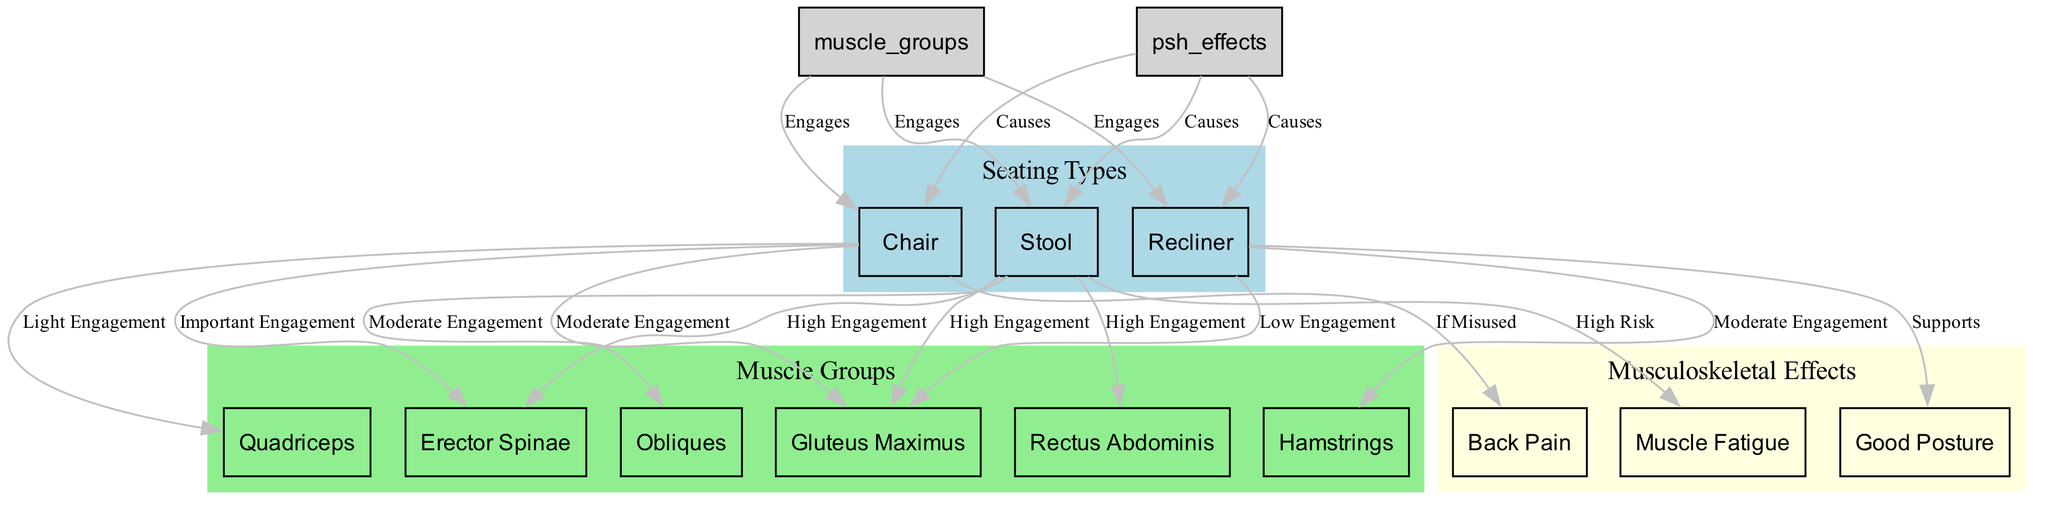What is the label for the first node in the seating types cluster? The first node in the seating types cluster is the "Chair," which is labeled as "Standard seating with back support."
Answer: Chair Which muscle group is highly engaged by the stool? According to the diagram, the muscle groups that are highly engaged by the stool include the "Gluteus Maximus," "Erector Spinae," and "Rectus Abdominis."
Answer: Gluteus Maximus, Erector Spinae, Rectus Abdominis What kind of seating supports good posture? The diagram indicates that "Recliner" supports good posture while sitting.
Answer: Recliner How many edges are connected to the muscle group node? Upon examining the edges connected to the muscle group node, there are a total of 3 edges connecting to the chair, stool, and recliner.
Answer: 3 What is the potential risk associated with prolonged use of a stool? The diagram specifies that the stool presents a "High Risk" of muscle fatigue due to the lack of back support and prolonged use.
Answer: Muscle Fatigue Which seating type has moderate engagement of the gluteus maximus? The diagram shows that the "Chair" engages the gluteus maximus with a moderate level of engagement.
Answer: Chair What effect does the misuse of a chair have on musculoskeletal health? According to the diagram, the misuse of a chair can lead to "Back Pain."
Answer: Back Pain Which muscle group is involved in the engagement of the recliner? The diagram indicates that the hamstrings have a "Moderate Engagement" when using a recliner.
Answer: Hamstrings How many muscle groups are identified in the muscle groups cluster? There are a total of 6 muscle groups identified in the muscle groups cluster, namely gluteus maximus, erector spinae, quadriceps, hamstrings, rectus abdominis, and obliques.
Answer: 6 